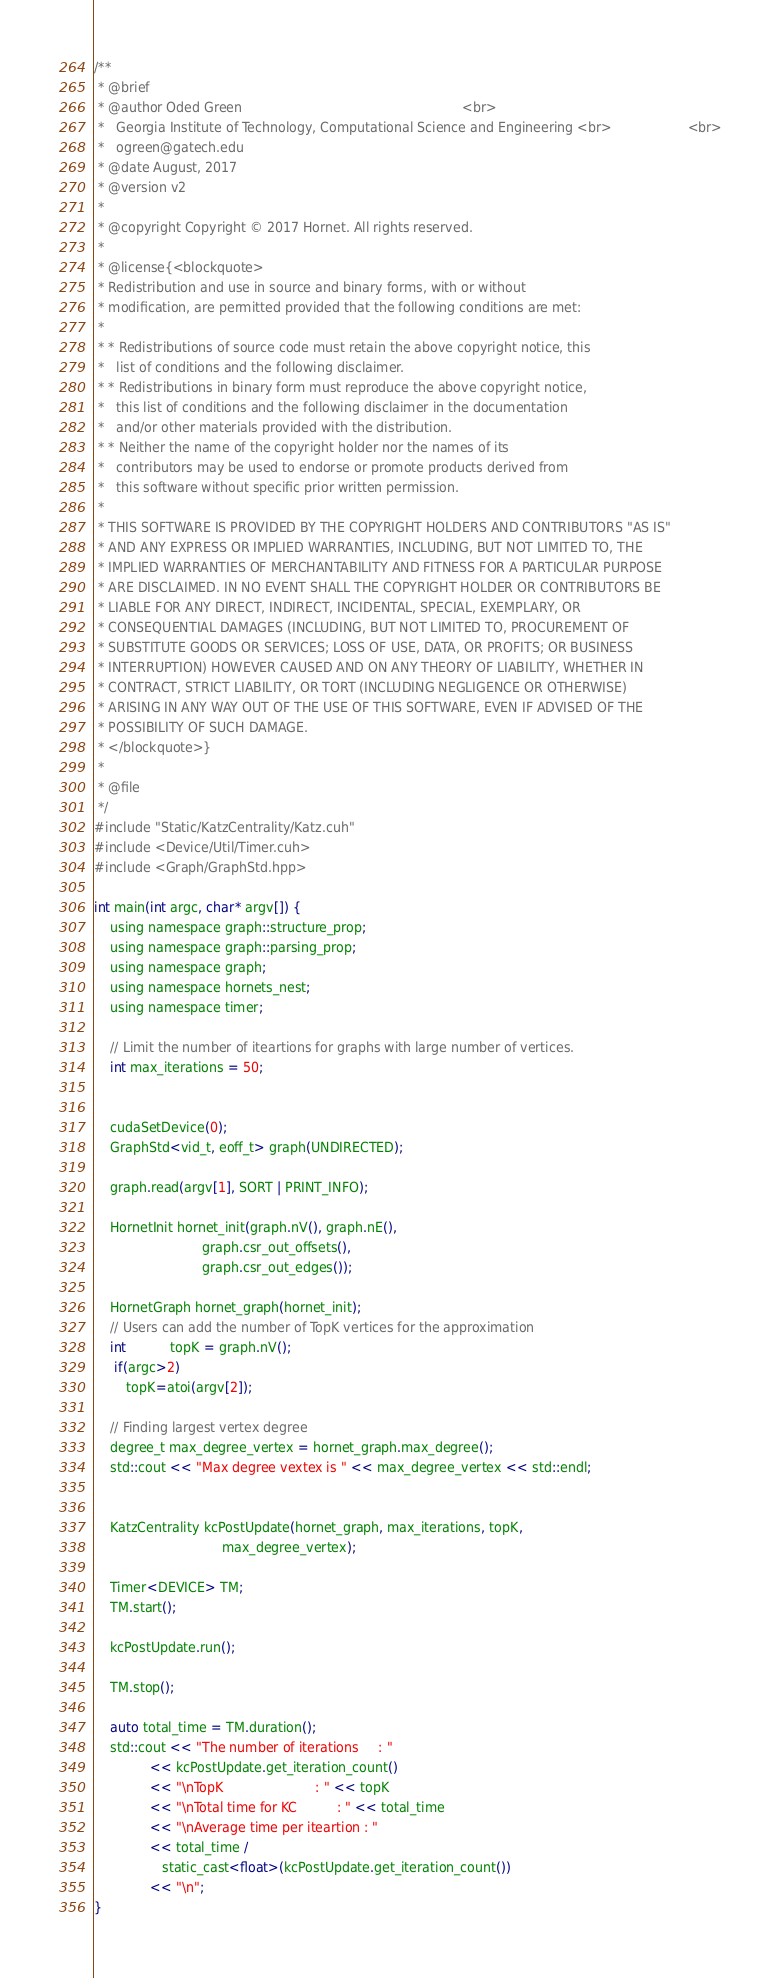<code> <loc_0><loc_0><loc_500><loc_500><_Cuda_>/**
 * @brief
 * @author Oded Green                                                       <br>
 *   Georgia Institute of Technology, Computational Science and Engineering <br>                   <br>
 *   ogreen@gatech.edu
 * @date August, 2017
 * @version v2
 *
 * @copyright Copyright © 2017 Hornet. All rights reserved.
 *
 * @license{<blockquote>
 * Redistribution and use in source and binary forms, with or without
 * modification, are permitted provided that the following conditions are met:
 *
 * * Redistributions of source code must retain the above copyright notice, this
 *   list of conditions and the following disclaimer.
 * * Redistributions in binary form must reproduce the above copyright notice,
 *   this list of conditions and the following disclaimer in the documentation
 *   and/or other materials provided with the distribution.
 * * Neither the name of the copyright holder nor the names of its
 *   contributors may be used to endorse or promote products derived from
 *   this software without specific prior written permission.
 *
 * THIS SOFTWARE IS PROVIDED BY THE COPYRIGHT HOLDERS AND CONTRIBUTORS "AS IS"
 * AND ANY EXPRESS OR IMPLIED WARRANTIES, INCLUDING, BUT NOT LIMITED TO, THE
 * IMPLIED WARRANTIES OF MERCHANTABILITY AND FITNESS FOR A PARTICULAR PURPOSE
 * ARE DISCLAIMED. IN NO EVENT SHALL THE COPYRIGHT HOLDER OR CONTRIBUTORS BE
 * LIABLE FOR ANY DIRECT, INDIRECT, INCIDENTAL, SPECIAL, EXEMPLARY, OR
 * CONSEQUENTIAL DAMAGES (INCLUDING, BUT NOT LIMITED TO, PROCUREMENT OF
 * SUBSTITUTE GOODS OR SERVICES; LOSS OF USE, DATA, OR PROFITS; OR BUSINESS
 * INTERRUPTION) HOWEVER CAUSED AND ON ANY THEORY OF LIABILITY, WHETHER IN
 * CONTRACT, STRICT LIABILITY, OR TORT (INCLUDING NEGLIGENCE OR OTHERWISE)
 * ARISING IN ANY WAY OUT OF THE USE OF THIS SOFTWARE, EVEN IF ADVISED OF THE
 * POSSIBILITY OF SUCH DAMAGE.
 * </blockquote>}
 *
 * @file
 */
#include "Static/KatzCentrality/Katz.cuh"
#include <Device/Util/Timer.cuh>
#include <Graph/GraphStd.hpp>

int main(int argc, char* argv[]) {
    using namespace graph::structure_prop;
    using namespace graph::parsing_prop;
    using namespace graph;
    using namespace hornets_nest;
    using namespace timer;

	// Limit the number of iteartions for graphs with large number of vertices.
    int max_iterations = 50;


	cudaSetDevice(0);
    GraphStd<vid_t, eoff_t> graph(UNDIRECTED);
    
    graph.read(argv[1], SORT | PRINT_INFO);

    HornetInit hornet_init(graph.nV(), graph.nE(),
                           graph.csr_out_offsets(),
                           graph.csr_out_edges());

    HornetGraph hornet_graph(hornet_init);
	// Users can add the number of TopK vertices for the approximation
	int           topK = graph.nV();
     if(argc>2)
        topK=atoi(argv[2]);
 
    // Finding largest vertex degree
    degree_t max_degree_vertex = hornet_graph.max_degree();
    std::cout << "Max degree vextex is " << max_degree_vertex << std::endl;


    KatzCentrality kcPostUpdate(hornet_graph, max_iterations, topK,
                                max_degree_vertex);

    Timer<DEVICE> TM;
    TM.start();

    kcPostUpdate.run();

    TM.stop();

    auto total_time = TM.duration();
    std::cout << "The number of iterations     : "
              << kcPostUpdate.get_iteration_count()
              << "\nTopK                       : " << topK 
              << "\nTotal time for KC          : " << total_time
              << "\nAverage time per iteartion : "
              << total_time /
                 static_cast<float>(kcPostUpdate.get_iteration_count())
              << "\n";
}
</code> 